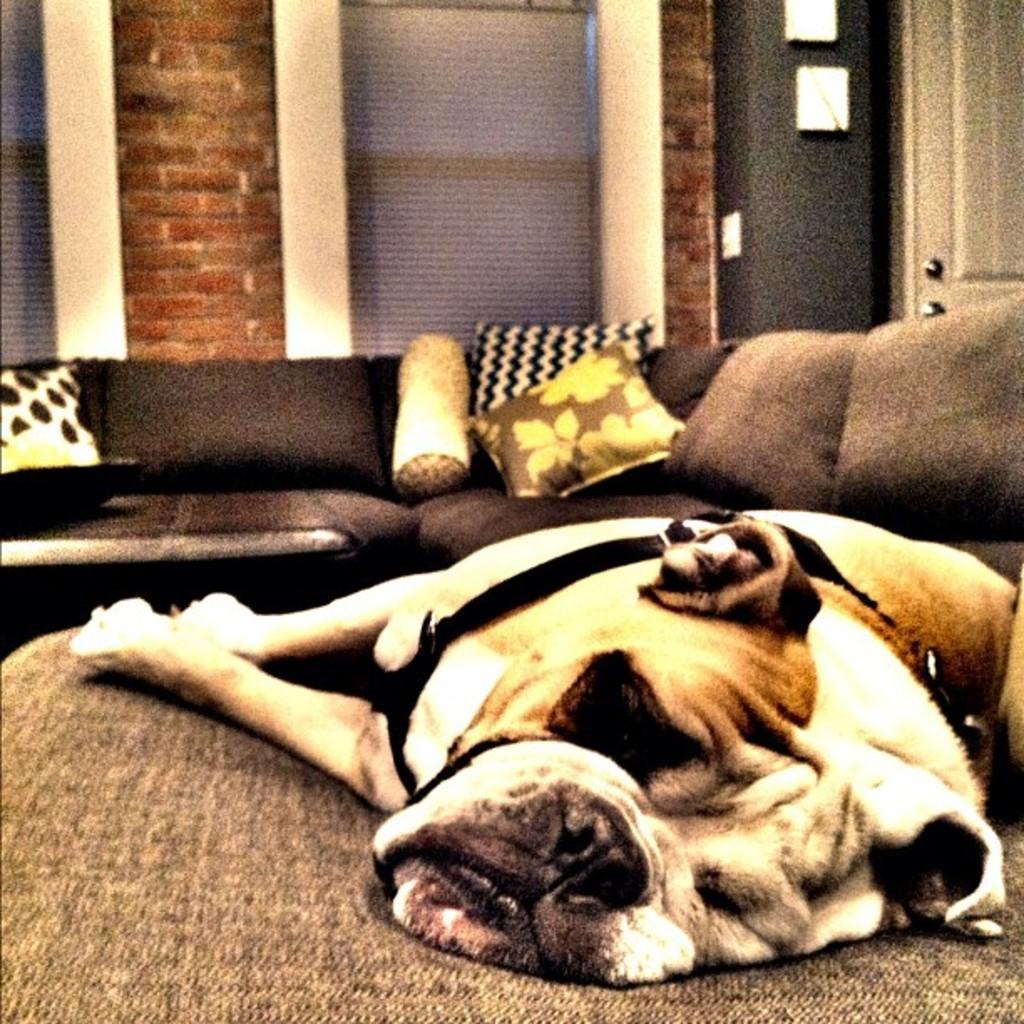Please provide a concise description of this image. This picture is clicked inside the room. In the foreground there is dog seems to be sleeping on a table. In the center we can see the couch containing some pillows. In the background we can see the brick wall and the door. 